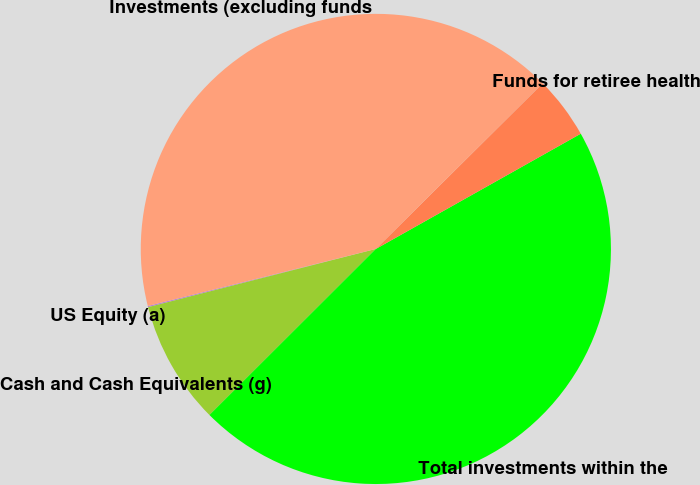Convert chart to OTSL. <chart><loc_0><loc_0><loc_500><loc_500><pie_chart><fcel>US Equity (a)<fcel>Cash and Cash Equivalents (g)<fcel>Total investments within the<fcel>Funds for retiree health<fcel>Investments (excluding funds<nl><fcel>0.08%<fcel>8.5%<fcel>45.67%<fcel>4.29%<fcel>41.46%<nl></chart> 